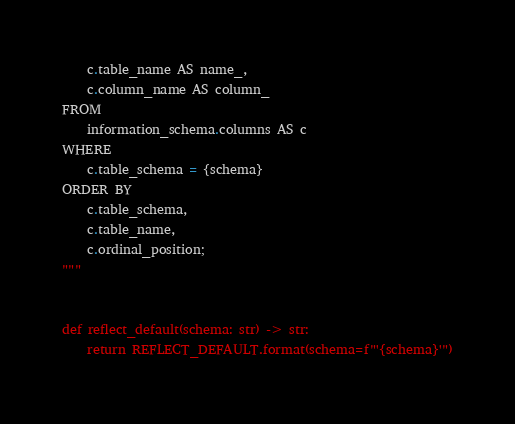<code> <loc_0><loc_0><loc_500><loc_500><_Python_>    c.table_name AS name_,
    c.column_name AS column_
FROM 
    information_schema.columns AS c
WHERE
    c.table_schema = {schema}
ORDER BY
    c.table_schema,
    c.table_name,
    c.ordinal_position;
"""


def reflect_default(schema: str) -> str:
    return REFLECT_DEFAULT.format(schema=f"'{schema}'")

</code> 